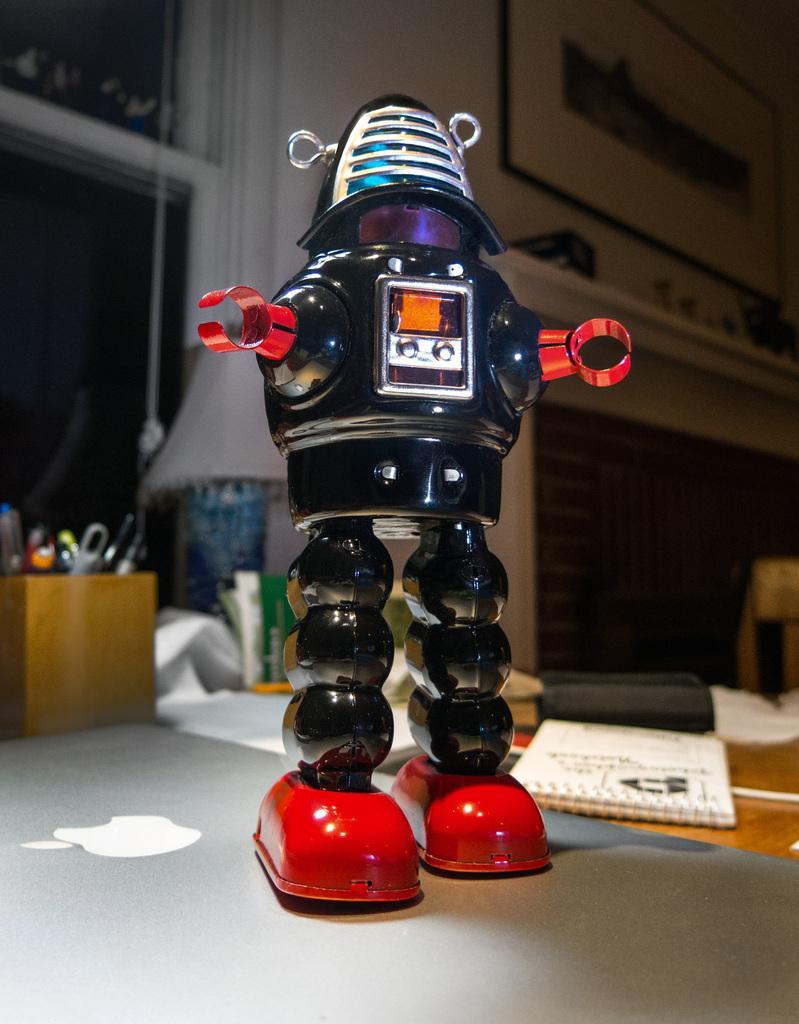Could you give a brief overview of what you see in this image? In the image there is a robot standing on laptop and behind there is a pen stand,books,lamp,papers on a table and behind it there is a window on the wall. 